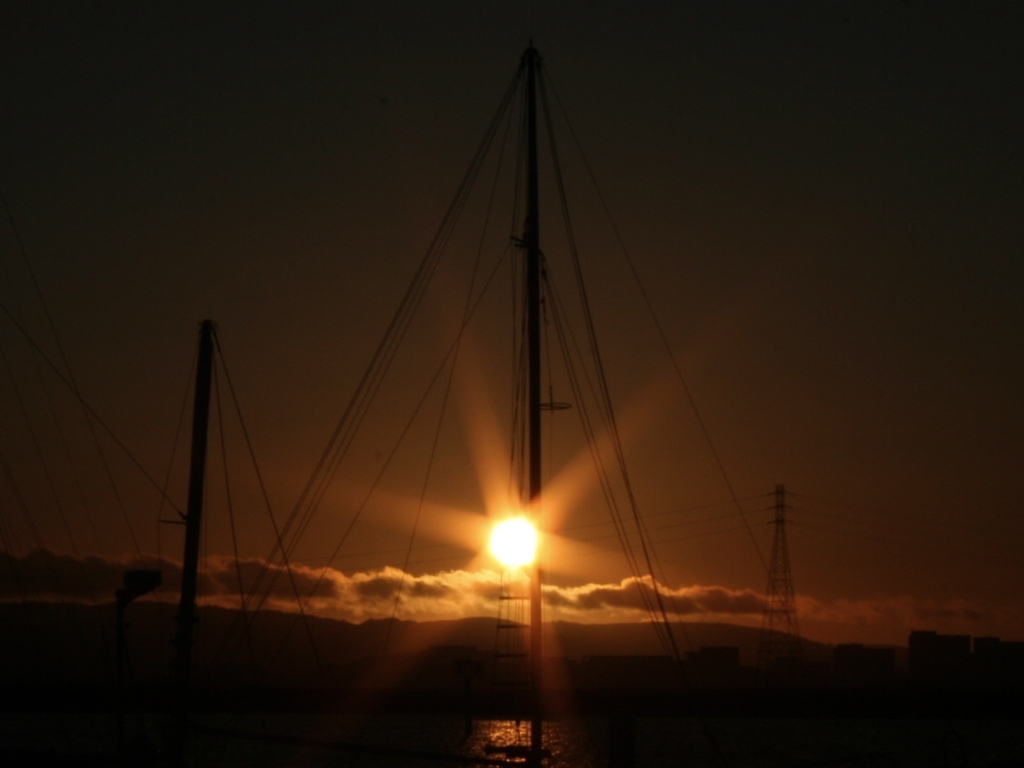Describe the atmosphere or mood that this image conveys. The image evokes a sense of calmness and serenity, typical of a sunset viewed from a quiet marina. The sun's glow casts a warm hue across the scene, providing a tranquil end to the day with a hint of reflection and peace. 